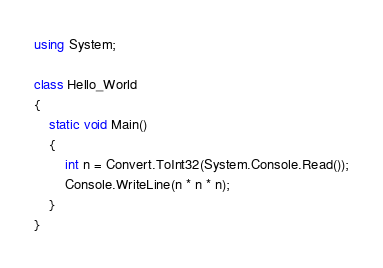<code> <loc_0><loc_0><loc_500><loc_500><_C#_>using System;

class Hello_World
{
    static void Main()
    {
        int n = Convert.ToInt32(System.Console.Read());
        Console.WriteLine(n * n * n);
    }
}</code> 